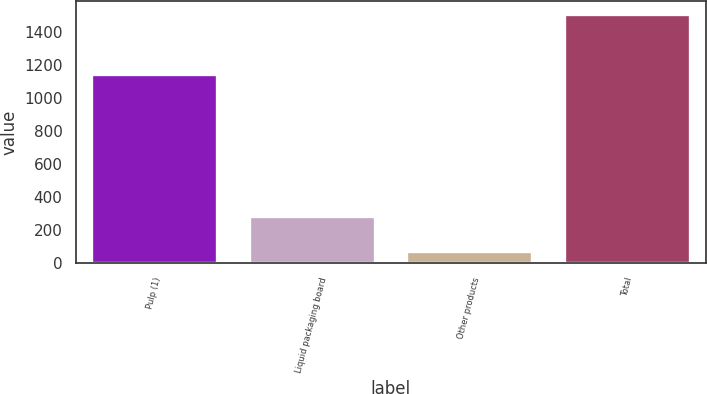Convert chart. <chart><loc_0><loc_0><loc_500><loc_500><bar_chart><fcel>Pulp (1)<fcel>Liquid packaging board<fcel>Other products<fcel>Total<nl><fcel>1148<fcel>290<fcel>73<fcel>1511<nl></chart> 